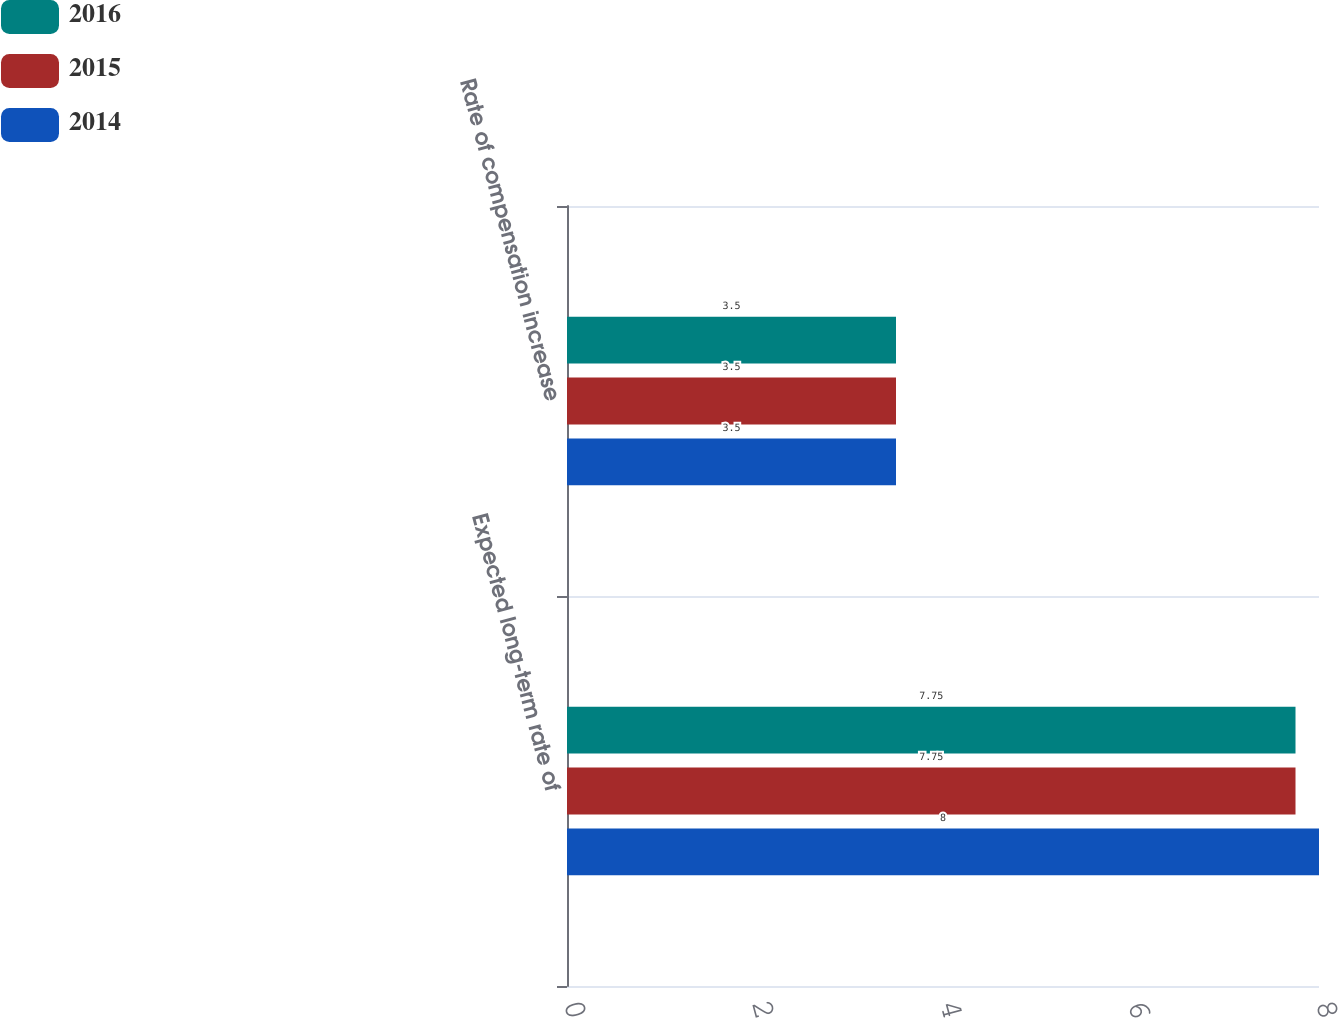Convert chart. <chart><loc_0><loc_0><loc_500><loc_500><stacked_bar_chart><ecel><fcel>Expected long-term rate of<fcel>Rate of compensation increase<nl><fcel>2016<fcel>7.75<fcel>3.5<nl><fcel>2015<fcel>7.75<fcel>3.5<nl><fcel>2014<fcel>8<fcel>3.5<nl></chart> 